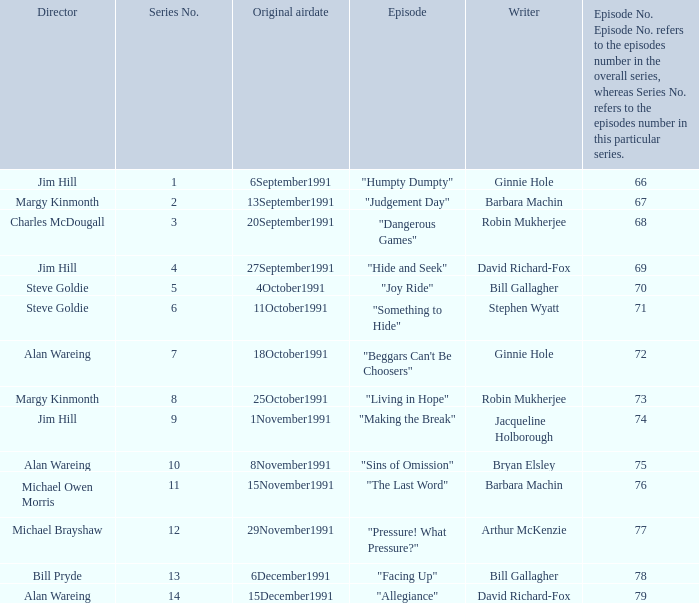Name the least series number for episode number being 78 13.0. 